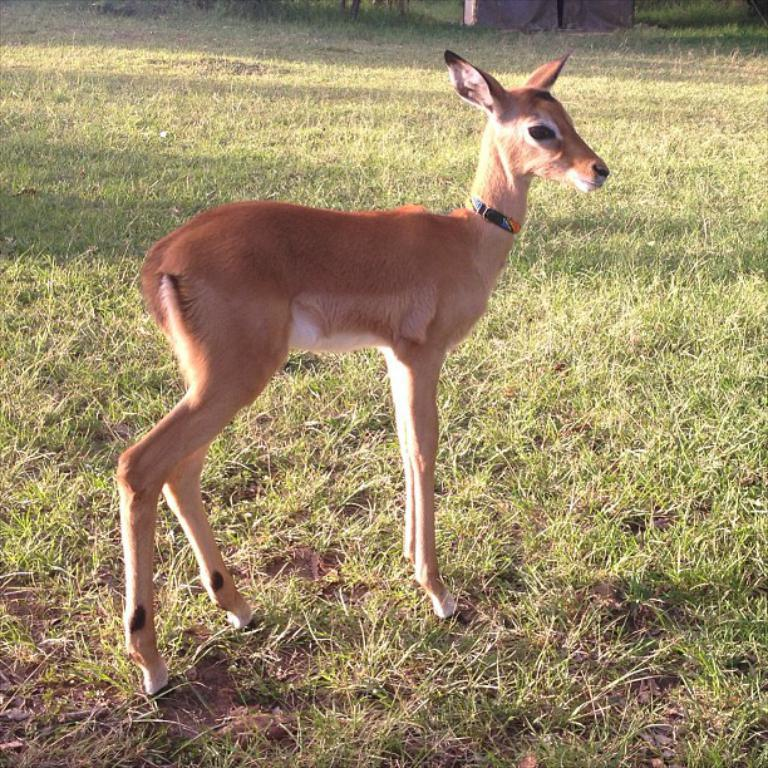What animal is in the center of the image? There is a deer in the center of the image. What type of vegetation is present in the image? There is grass in the image. What type of ground is visible in the image? There is soil in the image. What can be seen at the top of the image? There is an object at the top of the image. What type of mint is growing in the image? There is no mint present in the image; it features a deer, grass, soil, and an object at the top. How many quarters can be seen in the image? There are no quarters present in the image. 